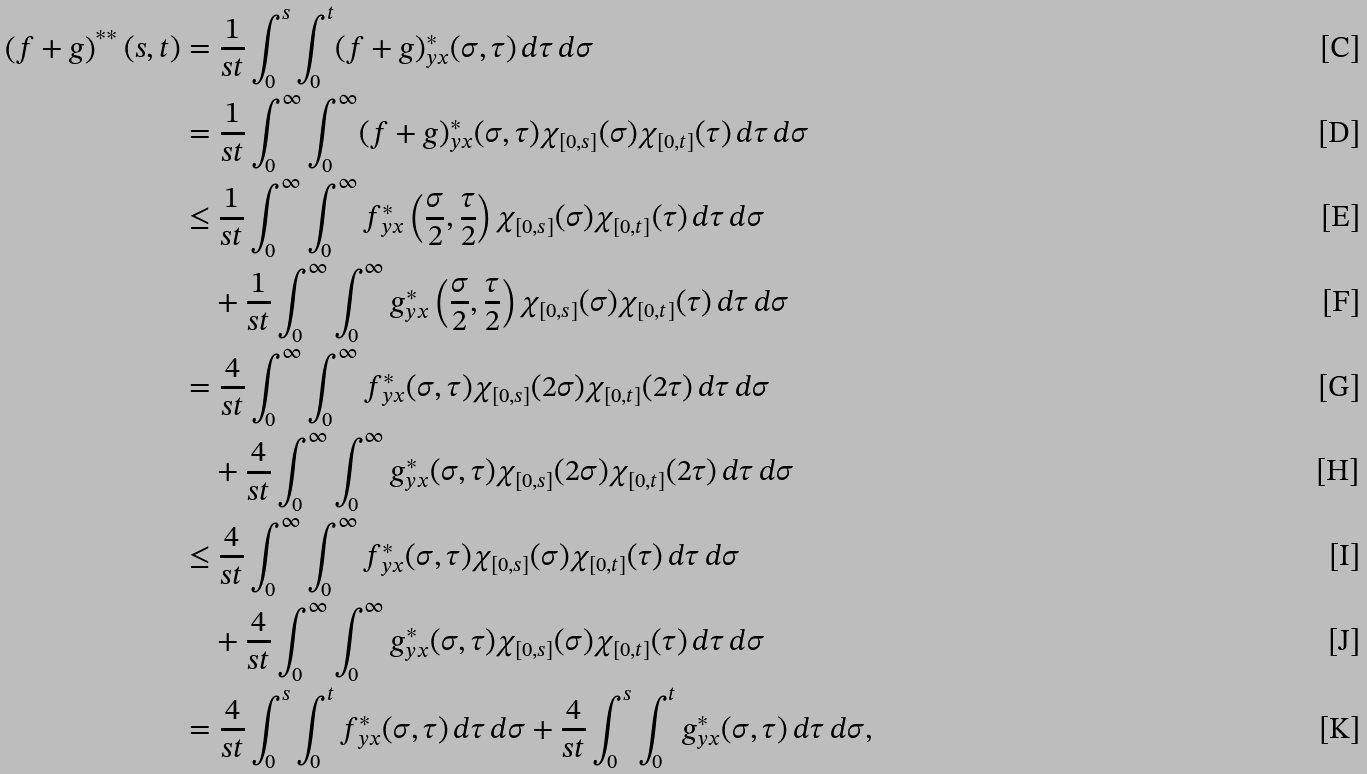<formula> <loc_0><loc_0><loc_500><loc_500>\left ( f + g \right ) ^ { \ast \ast } ( s , t ) & = \frac { 1 } { s t } \int _ { 0 } ^ { s } \int _ { 0 } ^ { t } ( f + g ) _ { y x } ^ { \ast } ( \sigma , \tau ) \, d \tau \, d \sigma \\ & = \frac { 1 } { s t } \int _ { 0 } ^ { \infty } \int _ { 0 } ^ { \infty } ( f + g ) _ { y x } ^ { \ast } ( \sigma , \tau ) \chi _ { [ 0 , s ] } ( \sigma ) \chi _ { [ 0 , t ] } ( \tau ) \, d \tau \, d \sigma \\ & \leq \frac { 1 } { s t } \int _ { 0 } ^ { \infty } \int _ { 0 } ^ { \infty } f _ { y x } ^ { \ast } \left ( \frac { \sigma } { 2 } , \frac { \tau } { 2 } \right ) \chi _ { [ 0 , s ] } ( \sigma ) \chi _ { [ 0 , t ] } ( \tau ) \, d \tau \, d \sigma \\ & \quad + \frac { 1 } { s t } \int _ { 0 } ^ { \infty } \int _ { 0 } ^ { \infty } g _ { y x } ^ { \ast } \left ( \frac { \sigma } { 2 } , \frac { \tau } { 2 } \right ) \chi _ { [ 0 , s ] } ( \sigma ) \chi _ { [ 0 , t ] } ( \tau ) \, d \tau \, d \sigma \\ & = \frac { 4 } { s t } \int _ { 0 } ^ { \infty } \int _ { 0 } ^ { \infty } f _ { y x } ^ { \ast } ( \sigma , \tau ) \chi _ { [ 0 , s ] } ( 2 \sigma ) \chi _ { [ 0 , t ] } ( 2 \tau ) \, d \tau \, d \sigma \\ & \quad + \frac { 4 } { s t } \int _ { 0 } ^ { \infty } \int _ { 0 } ^ { \infty } g _ { y x } ^ { \ast } ( \sigma , \tau ) \chi _ { [ 0 , s ] } ( 2 \sigma ) \chi _ { [ 0 , t ] } ( 2 \tau ) \, d \tau \, d \sigma \\ & \leq \frac { 4 } { s t } \int _ { 0 } ^ { \infty } \int _ { 0 } ^ { \infty } f _ { y x } ^ { \ast } ( \sigma , \tau ) \chi _ { [ 0 , s ] } ( \sigma ) \chi _ { [ 0 , t ] } ( \tau ) \, d \tau \, d \sigma \\ & \quad + \frac { 4 } { s t } \int _ { 0 } ^ { \infty } \int _ { 0 } ^ { \infty } g _ { y x } ^ { \ast } ( \sigma , \tau ) \chi _ { [ 0 , s ] } ( \sigma ) \chi _ { [ 0 , t ] } ( \tau ) \, d \tau \, d \sigma \\ & = \frac { 4 } { s t } \int _ { 0 } ^ { s } \int _ { 0 } ^ { t } f _ { y x } ^ { \ast } ( \sigma , \tau ) \, d \tau \, d \sigma + \frac { 4 } { s t } \int _ { 0 } ^ { s } \int _ { 0 } ^ { t } g _ { y x } ^ { \ast } ( \sigma , \tau ) \, d \tau \, d \sigma ,</formula> 